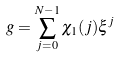Convert formula to latex. <formula><loc_0><loc_0><loc_500><loc_500>g = \sum _ { j = 0 } ^ { N - 1 } \chi _ { 1 } ( j ) \xi ^ { j }</formula> 